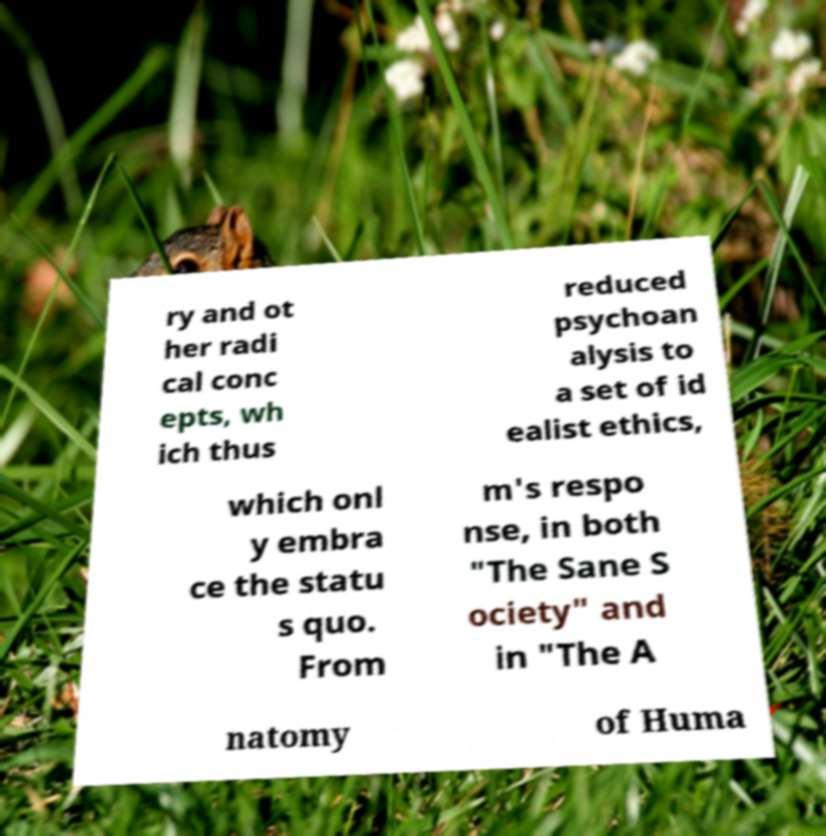Could you extract and type out the text from this image? ry and ot her radi cal conc epts, wh ich thus reduced psychoan alysis to a set of id ealist ethics, which onl y embra ce the statu s quo. From m's respo nse, in both "The Sane S ociety" and in "The A natomy of Huma 